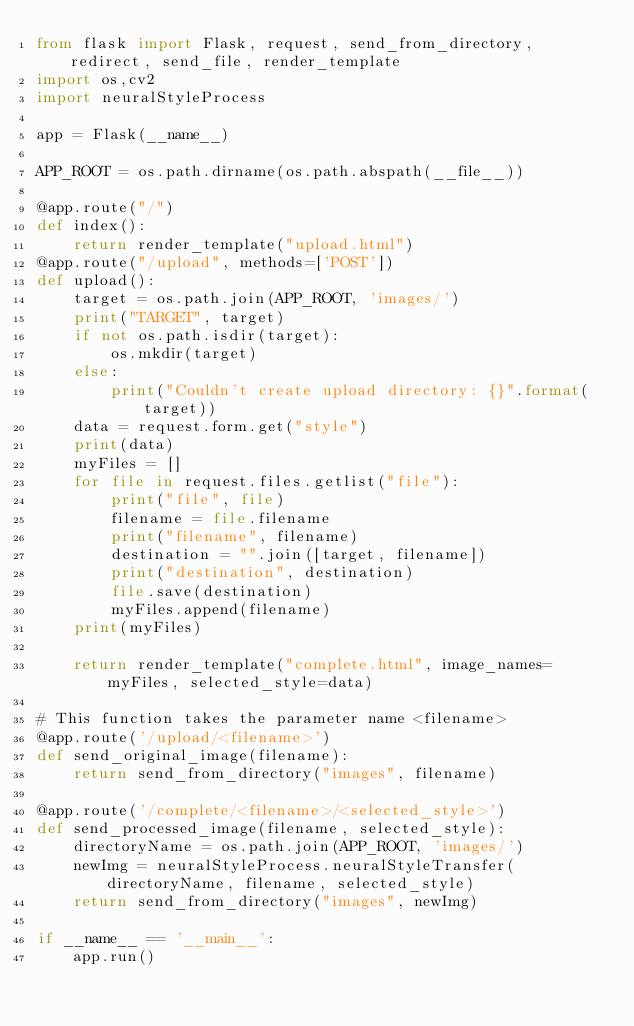<code> <loc_0><loc_0><loc_500><loc_500><_Python_>from flask import Flask, request, send_from_directory, redirect, send_file, render_template
import os,cv2
import neuralStyleProcess

app = Flask(__name__)

APP_ROOT = os.path.dirname(os.path.abspath(__file__))

@app.route("/")
def index():
	return render_template("upload.html")
@app.route("/upload", methods=['POST'])
def upload():
	target = os.path.join(APP_ROOT, 'images/')
	print("TARGET", target)
	if not os.path.isdir(target):
		os.mkdir(target)
	else:
		print("Couldn't create upload directory: {}".format(target))
	data = request.form.get("style")
	print(data)
	myFiles = []
	for file in request.files.getlist("file"):
		print("file", file)
		filename = file.filename
		print("filename", filename)
		destination = "".join([target, filename])
		print("destination", destination)
		file.save(destination)
		myFiles.append(filename)
	print(myFiles)

	return render_template("complete.html", image_names=myFiles, selected_style=data)

# This function takes the parameter name <filename>
@app.route('/upload/<filename>')
def send_original_image(filename):
	return send_from_directory("images", filename)

@app.route('/complete/<filename>/<selected_style>')
def send_processed_image(filename, selected_style):
	directoryName = os.path.join(APP_ROOT, 'images/')
	newImg = neuralStyleProcess.neuralStyleTransfer(directoryName, filename, selected_style)
	return send_from_directory("images", newImg)

if __name__ == '__main__':
    app.run()
</code> 